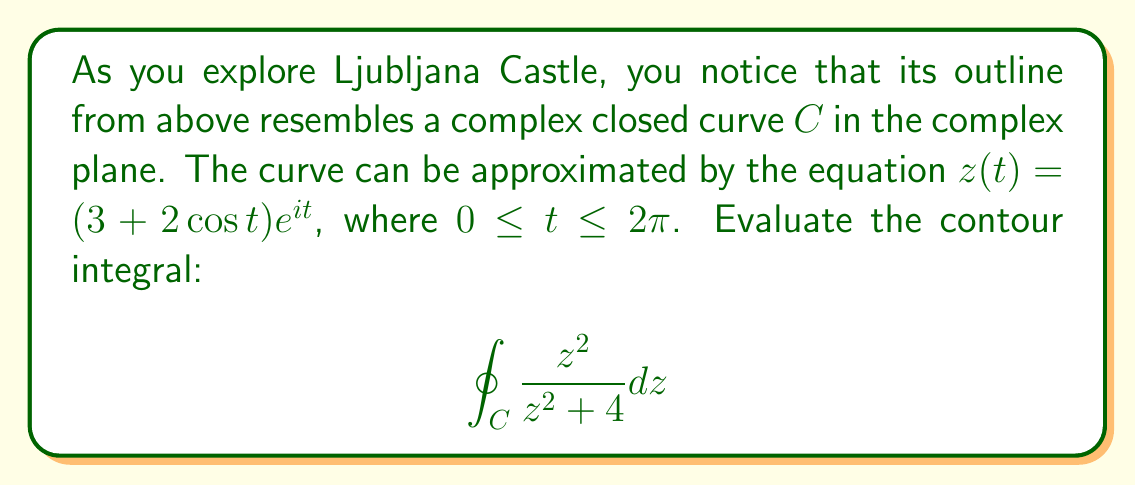Provide a solution to this math problem. Let's approach this problem step-by-step using the methods of complex analysis:

1) First, we need to identify the singularities of the integrand $f(z) = \frac{z^2}{z^2+4}$ inside the contour $C$. The denominator is zero when:

   $z^2 = -4$
   $z = \pm 2i$

2) The contour $C$ is given by $z(t) = (3+2\cos t)e^{it}$. To determine if the singularities are inside $C$, we need to find the minimum and maximum values of $|z(t)|$:

   $1 \leq 3+2\cos t \leq 5$

   So, $C$ encloses both singularities at $\pm 2i$.

3) We can use the residue theorem:

   $$\oint_C f(z)dz = 2\pi i \sum \text{Res}(f, a_k)$$

   where $a_k$ are the singularities inside $C$.

4) To find the residues, we use the formula for simple poles:

   $\text{Res}(f, a) = \lim_{z \to a} (z-a)f(z)$

5) For $a = 2i$:
   
   $\text{Res}(f, 2i) = \lim_{z \to 2i} (z-2i)\frac{z^2}{z^2+4} = \lim_{z \to 2i} \frac{z^2}{z+2i} = \frac{(2i)^2}{2i+2i} = -1$

6) For $a = -2i$:
   
   $\text{Res}(f, -2i) = \lim_{z \to -2i} (z+2i)\frac{z^2}{z^2+4} = \lim_{z \to -2i} \frac{z^2}{z-2i} = \frac{(-2i)^2}{-2i-2i} = -1$

7) Applying the residue theorem:

   $$\oint_C \frac{z^2}{z^2+4} dz = 2\pi i (-1 - 1) = -4\pi i$$
Answer: $-4\pi i$ 